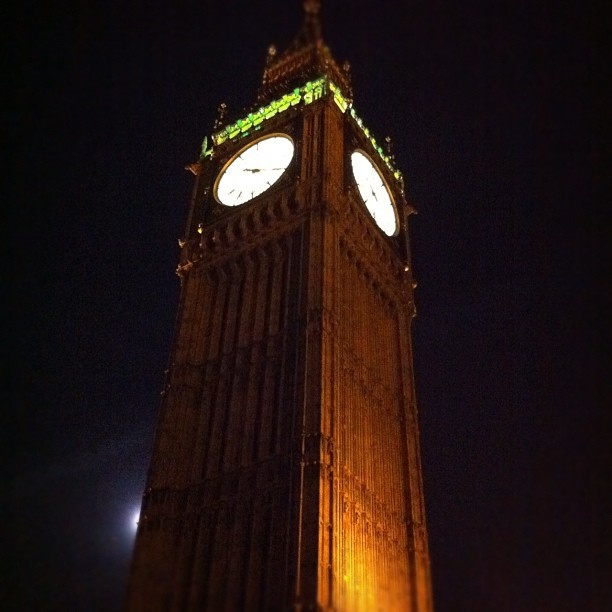Describe the objects in this image and their specific colors. I can see clock in black, white, darkgray, olive, and gray tones and clock in black, white, maroon, and gray tones in this image. 